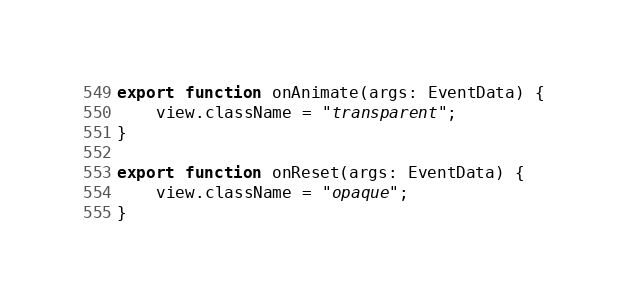Convert code to text. <code><loc_0><loc_0><loc_500><loc_500><_TypeScript_>export function onAnimate(args: EventData) {
    view.className = "transparent";
}

export function onReset(args: EventData) {
    view.className = "opaque";
}
</code> 